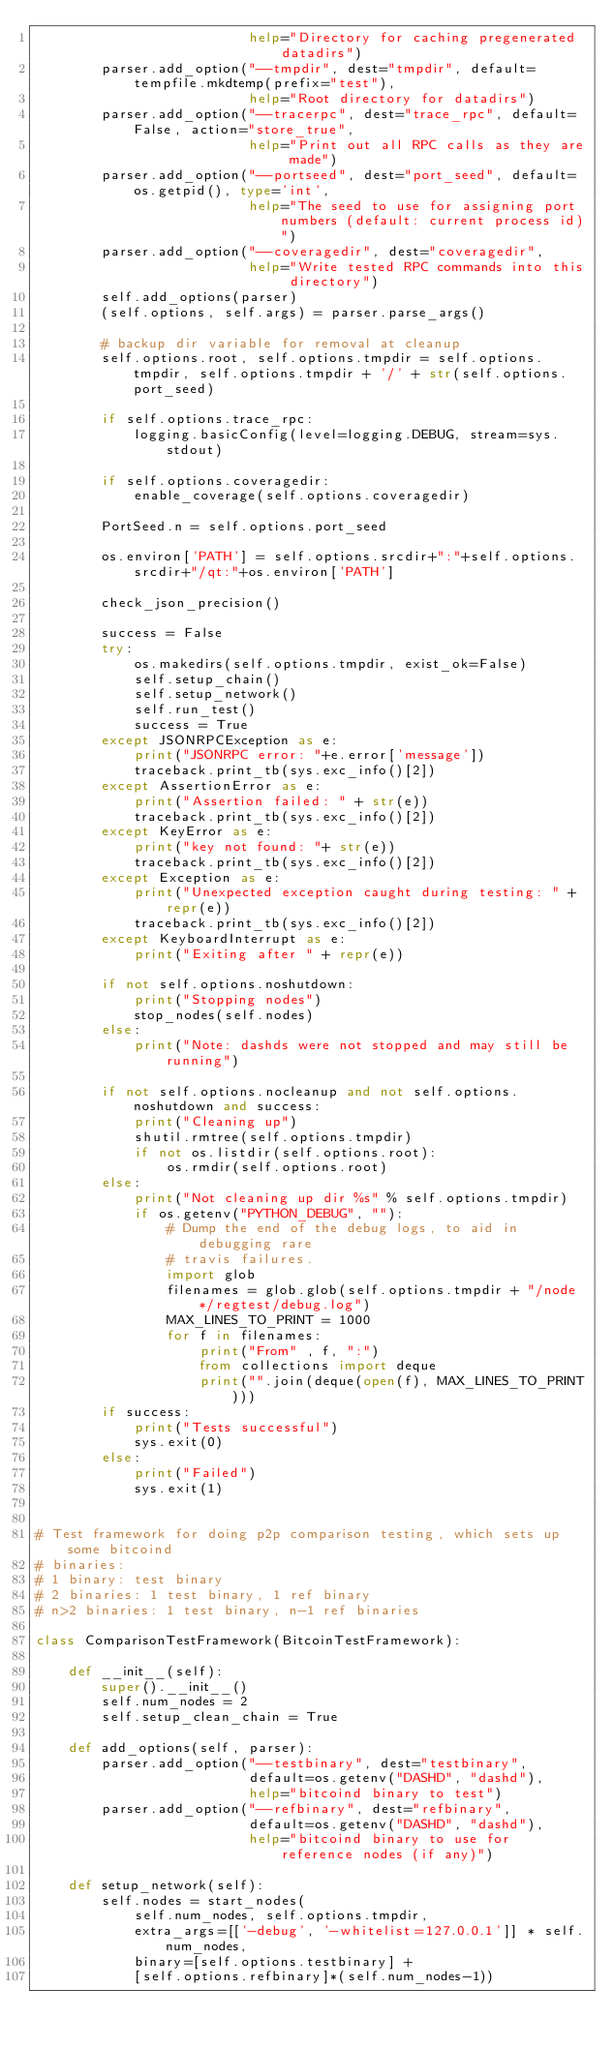<code> <loc_0><loc_0><loc_500><loc_500><_Python_>                          help="Directory for caching pregenerated datadirs")
        parser.add_option("--tmpdir", dest="tmpdir", default=tempfile.mkdtemp(prefix="test"),
                          help="Root directory for datadirs")
        parser.add_option("--tracerpc", dest="trace_rpc", default=False, action="store_true",
                          help="Print out all RPC calls as they are made")
        parser.add_option("--portseed", dest="port_seed", default=os.getpid(), type='int',
                          help="The seed to use for assigning port numbers (default: current process id)")
        parser.add_option("--coveragedir", dest="coveragedir",
                          help="Write tested RPC commands into this directory")
        self.add_options(parser)
        (self.options, self.args) = parser.parse_args()

        # backup dir variable for removal at cleanup
        self.options.root, self.options.tmpdir = self.options.tmpdir, self.options.tmpdir + '/' + str(self.options.port_seed)

        if self.options.trace_rpc:
            logging.basicConfig(level=logging.DEBUG, stream=sys.stdout)

        if self.options.coveragedir:
            enable_coverage(self.options.coveragedir)

        PortSeed.n = self.options.port_seed

        os.environ['PATH'] = self.options.srcdir+":"+self.options.srcdir+"/qt:"+os.environ['PATH']

        check_json_precision()

        success = False
        try:
            os.makedirs(self.options.tmpdir, exist_ok=False)
            self.setup_chain()
            self.setup_network()
            self.run_test()
            success = True
        except JSONRPCException as e:
            print("JSONRPC error: "+e.error['message'])
            traceback.print_tb(sys.exc_info()[2])
        except AssertionError as e:
            print("Assertion failed: " + str(e))
            traceback.print_tb(sys.exc_info()[2])
        except KeyError as e:
            print("key not found: "+ str(e))
            traceback.print_tb(sys.exc_info()[2])
        except Exception as e:
            print("Unexpected exception caught during testing: " + repr(e))
            traceback.print_tb(sys.exc_info()[2])
        except KeyboardInterrupt as e:
            print("Exiting after " + repr(e))

        if not self.options.noshutdown:
            print("Stopping nodes")
            stop_nodes(self.nodes)
        else:
            print("Note: dashds were not stopped and may still be running")

        if not self.options.nocleanup and not self.options.noshutdown and success:
            print("Cleaning up")
            shutil.rmtree(self.options.tmpdir)
            if not os.listdir(self.options.root):
                os.rmdir(self.options.root)
        else:
            print("Not cleaning up dir %s" % self.options.tmpdir)
            if os.getenv("PYTHON_DEBUG", ""):
                # Dump the end of the debug logs, to aid in debugging rare
                # travis failures.
                import glob
                filenames = glob.glob(self.options.tmpdir + "/node*/regtest/debug.log")
                MAX_LINES_TO_PRINT = 1000
                for f in filenames:
                    print("From" , f, ":")
                    from collections import deque
                    print("".join(deque(open(f), MAX_LINES_TO_PRINT)))
        if success:
            print("Tests successful")
            sys.exit(0)
        else:
            print("Failed")
            sys.exit(1)


# Test framework for doing p2p comparison testing, which sets up some bitcoind
# binaries:
# 1 binary: test binary
# 2 binaries: 1 test binary, 1 ref binary
# n>2 binaries: 1 test binary, n-1 ref binaries

class ComparisonTestFramework(BitcoinTestFramework):

    def __init__(self):
        super().__init__()
        self.num_nodes = 2
        self.setup_clean_chain = True

    def add_options(self, parser):
        parser.add_option("--testbinary", dest="testbinary",
                          default=os.getenv("DASHD", "dashd"),
                          help="bitcoind binary to test")
        parser.add_option("--refbinary", dest="refbinary",
                          default=os.getenv("DASHD", "dashd"),
                          help="bitcoind binary to use for reference nodes (if any)")

    def setup_network(self):
        self.nodes = start_nodes(
            self.num_nodes, self.options.tmpdir,
            extra_args=[['-debug', '-whitelist=127.0.0.1']] * self.num_nodes,
            binary=[self.options.testbinary] +
            [self.options.refbinary]*(self.num_nodes-1))
</code> 